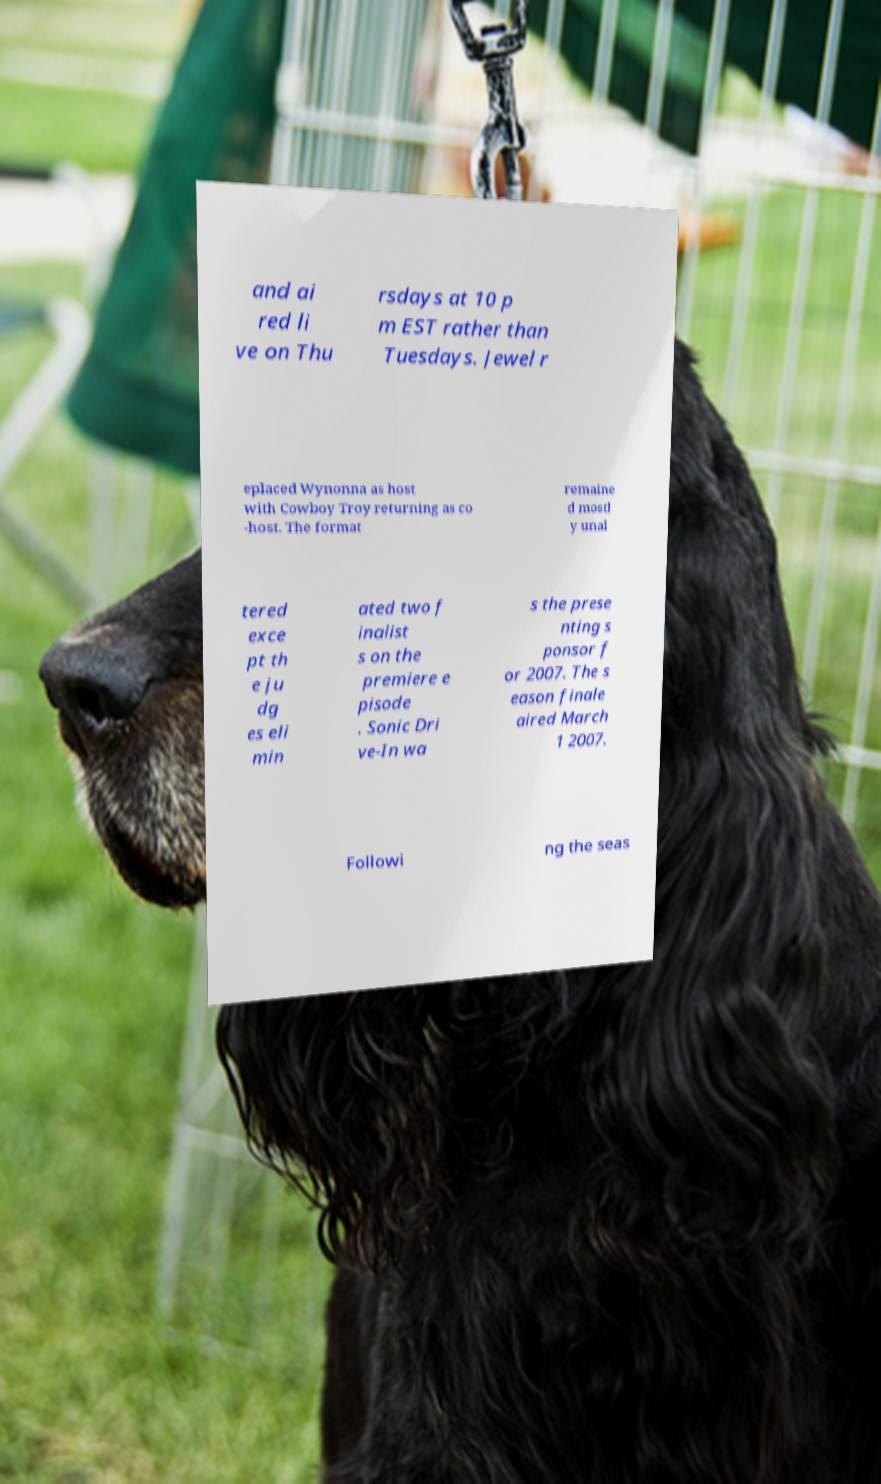What messages or text are displayed in this image? I need them in a readable, typed format. and ai red li ve on Thu rsdays at 10 p m EST rather than Tuesdays. Jewel r eplaced Wynonna as host with Cowboy Troy returning as co -host. The format remaine d mostl y unal tered exce pt th e ju dg es eli min ated two f inalist s on the premiere e pisode . Sonic Dri ve-In wa s the prese nting s ponsor f or 2007. The s eason finale aired March 1 2007. Followi ng the seas 